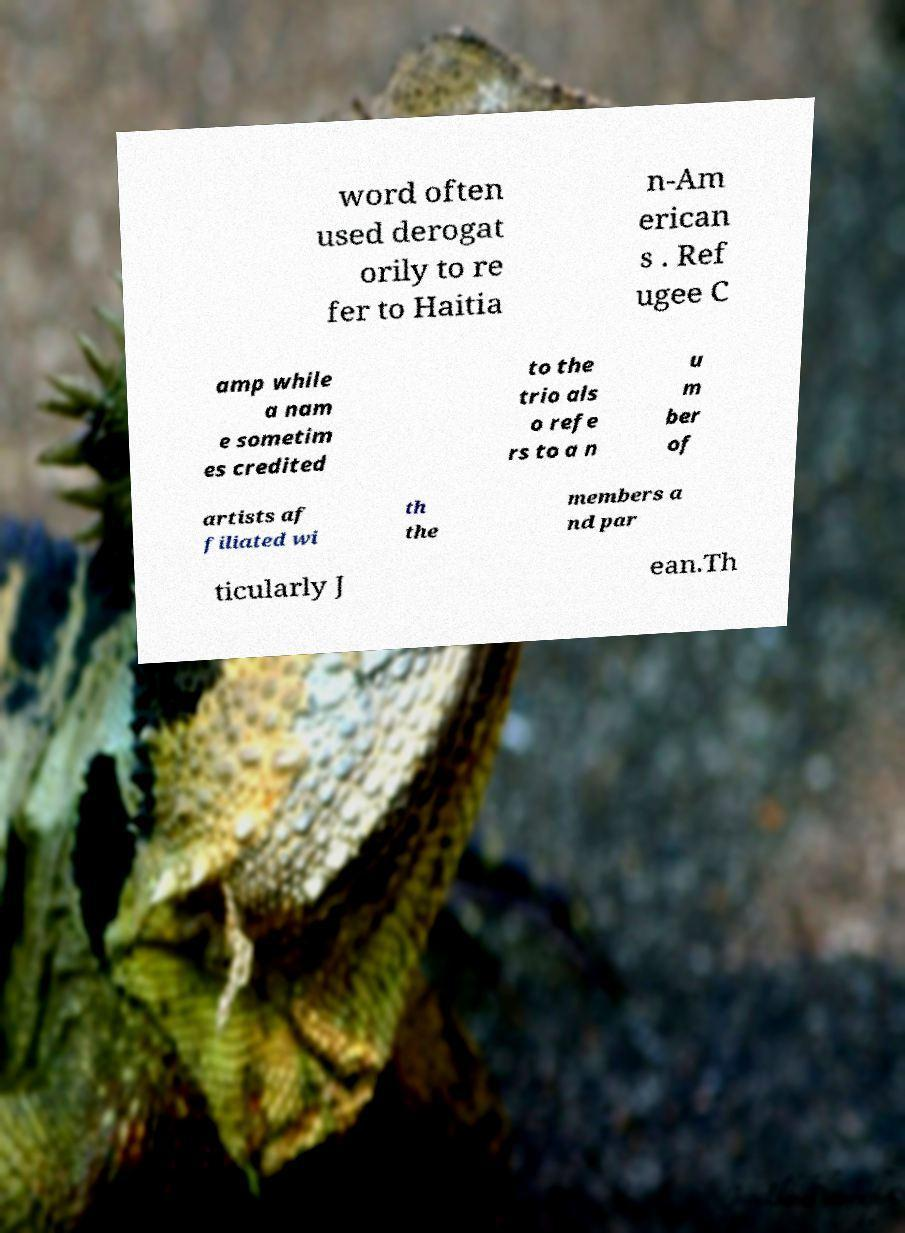For documentation purposes, I need the text within this image transcribed. Could you provide that? word often used derogat orily to re fer to Haitia n-Am erican s . Ref ugee C amp while a nam e sometim es credited to the trio als o refe rs to a n u m ber of artists af filiated wi th the members a nd par ticularly J ean.Th 